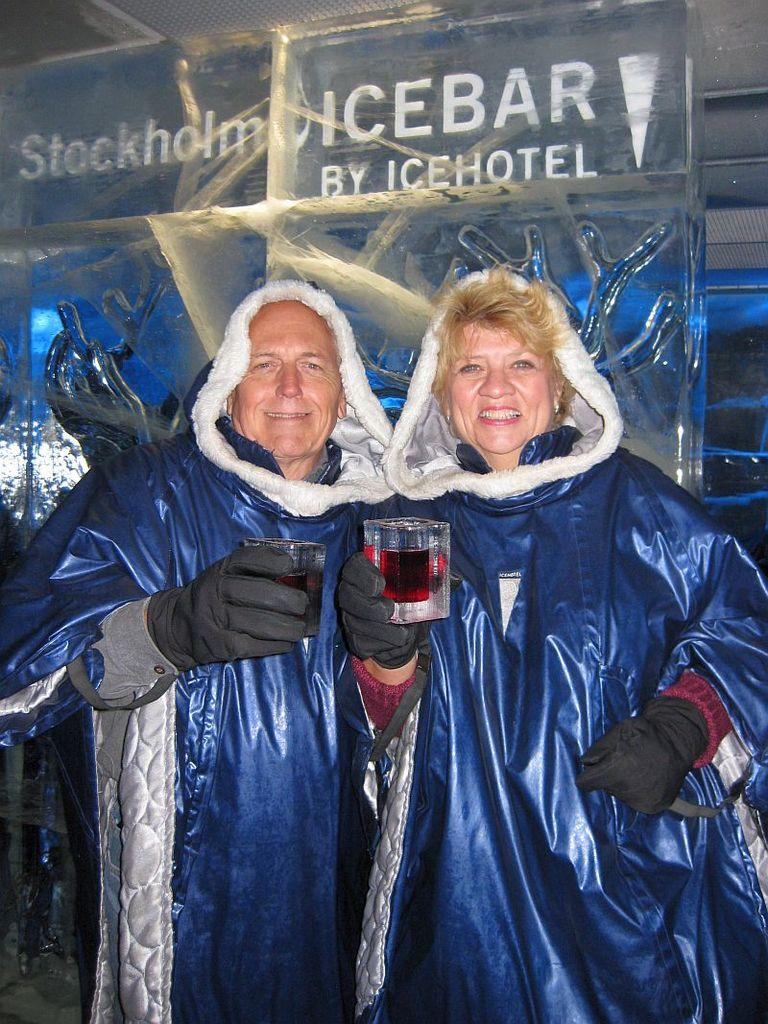<image>
Present a compact description of the photo's key features. A man and woman are wearing matching blue cloaks and standing under a sign that says Ice Hotel. 